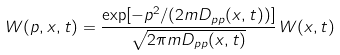<formula> <loc_0><loc_0><loc_500><loc_500>W ( p , x , t ) = \frac { \exp [ - p ^ { 2 } / ( 2 m D _ { p p } ( x , t ) ) ] } { \sqrt { 2 \pi m D _ { p p } ( x , t ) } } \, W ( x , t )</formula> 